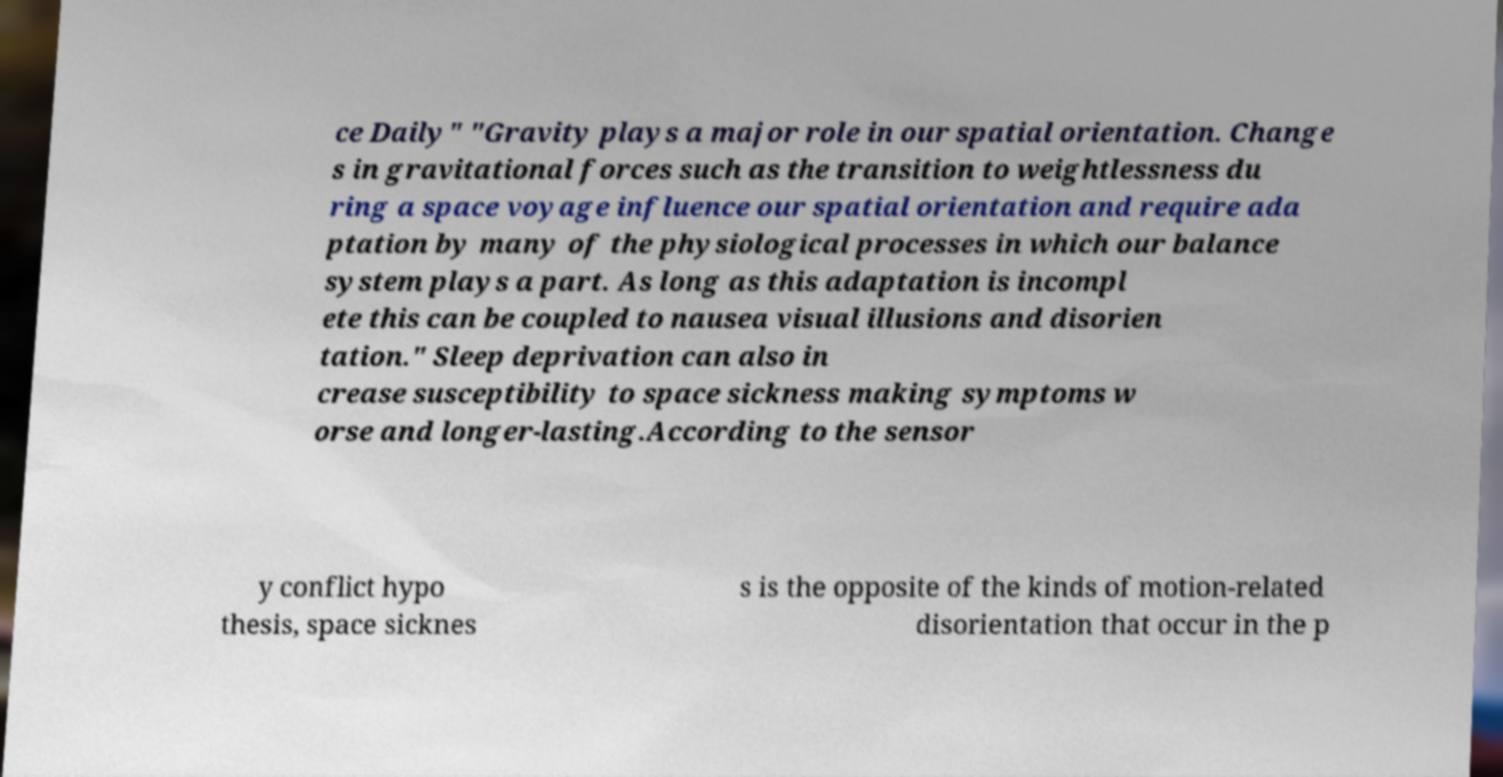Could you assist in decoding the text presented in this image and type it out clearly? ce Daily" "Gravity plays a major role in our spatial orientation. Change s in gravitational forces such as the transition to weightlessness du ring a space voyage influence our spatial orientation and require ada ptation by many of the physiological processes in which our balance system plays a part. As long as this adaptation is incompl ete this can be coupled to nausea visual illusions and disorien tation." Sleep deprivation can also in crease susceptibility to space sickness making symptoms w orse and longer-lasting.According to the sensor y conflict hypo thesis, space sicknes s is the opposite of the kinds of motion-related disorientation that occur in the p 